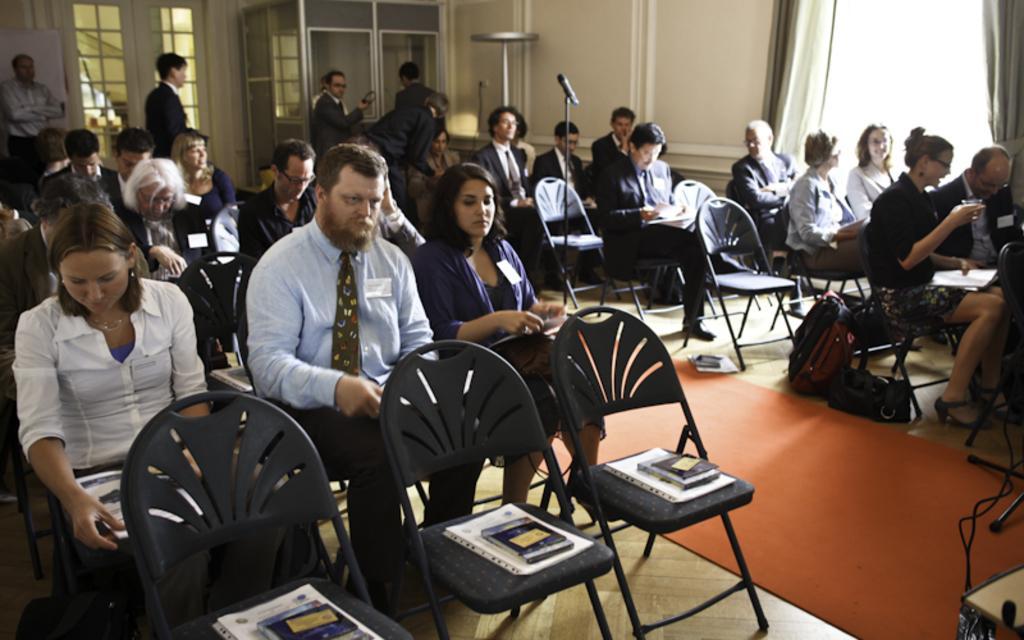Can you describe this image briefly? In this Image I see number of people who are sitting on chairs and few of them are standing. I can also few books on these chairs and there is a mic over here. In the background I see see the wall, windows and the curtains and I can also see few bags over here. 